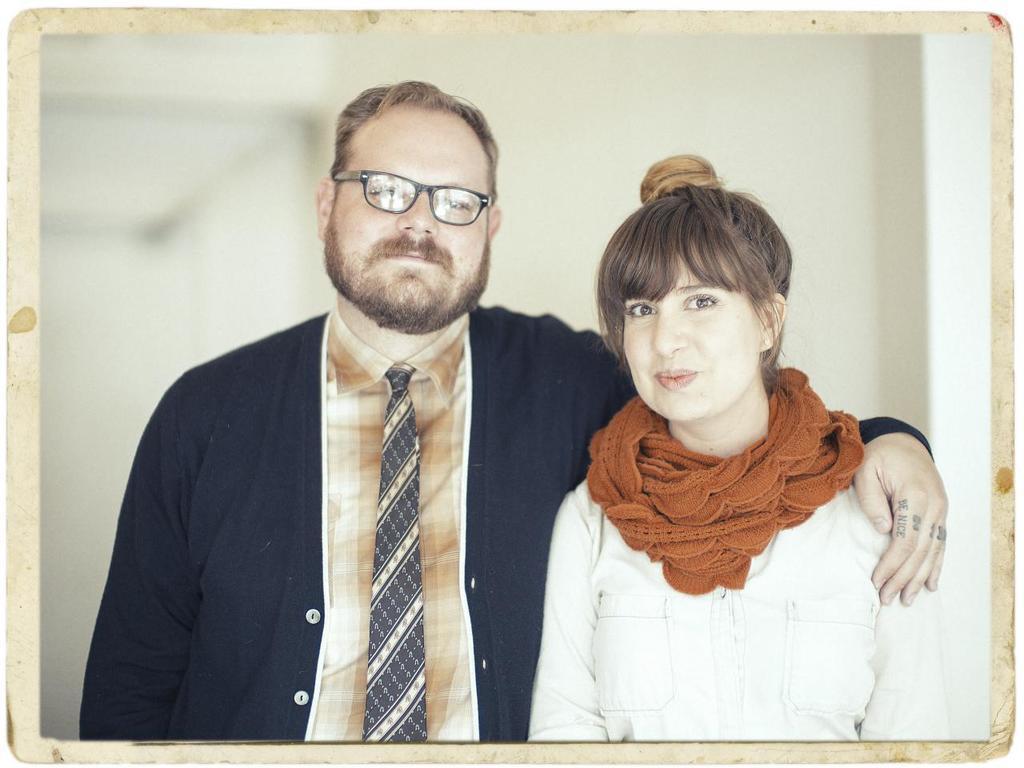Can you describe this image briefly? In the picture we can see a photograph in that we can see a man and a woman, a man is wearing a black suit and a tie and a shirt and a woman is wearing a white dress. 